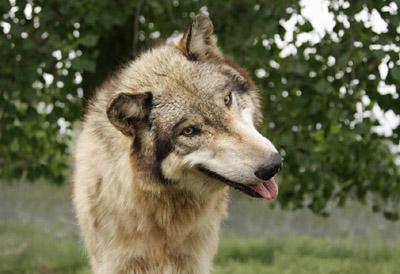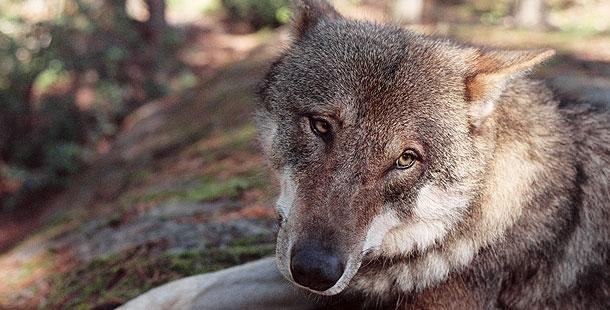The first image is the image on the left, the second image is the image on the right. Evaluate the accuracy of this statement regarding the images: "Each image contains one forward-turned wolf with its head held straight and level, and the gazes of the wolves on the right and left are aimed in the same direction.". Is it true? Answer yes or no. No. 